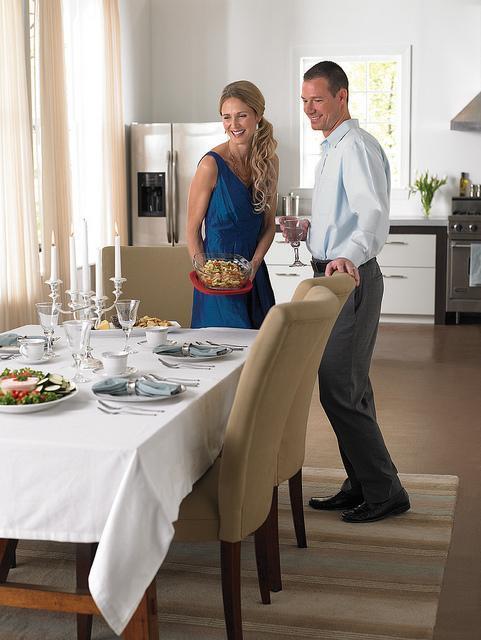How many candles are in the picture?
Give a very brief answer. 5. How many chairs are there?
Give a very brief answer. 3. How many people can be seen?
Give a very brief answer. 2. How many toilets are there?
Give a very brief answer. 0. 